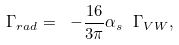<formula> <loc_0><loc_0><loc_500><loc_500>\Gamma _ { r a d } = \ - \frac { 1 6 } { 3 \pi } \alpha _ { s } \ \Gamma _ { V W } ,</formula> 